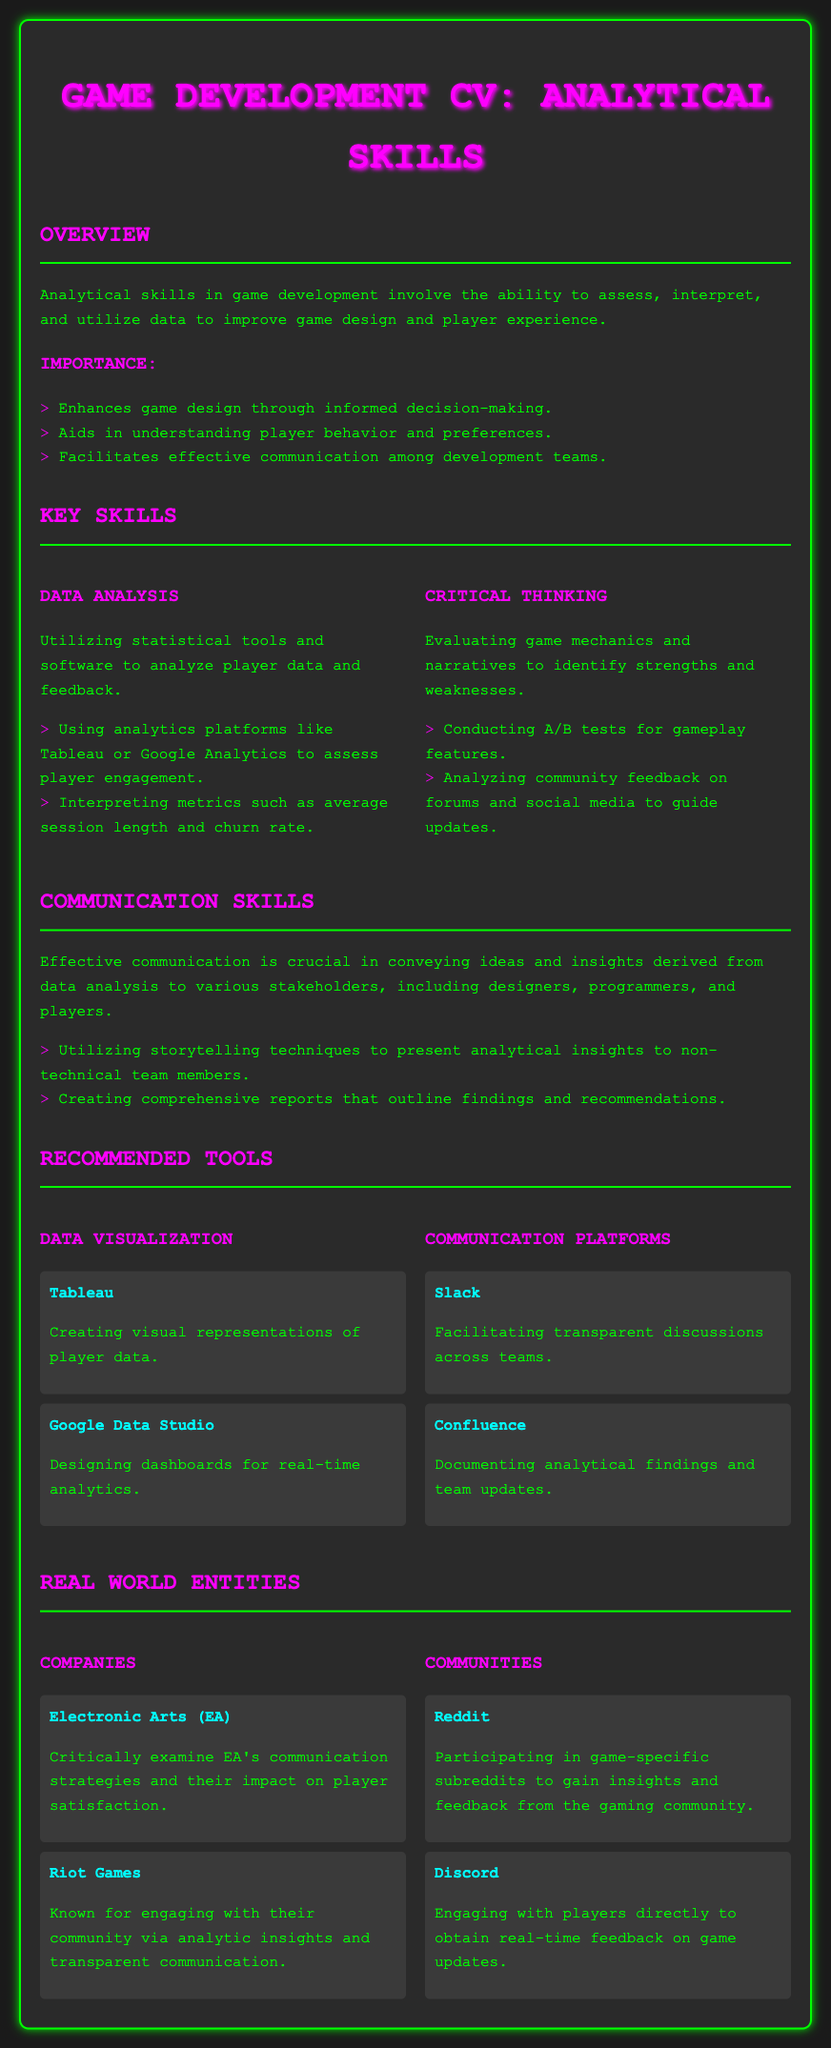what is the title of the document? The title of the document is mentioned in the <title> tag of the HTML, which is "Game Development CV - Analytical Skills."
Answer: Game Development CV - Analytical Skills how many key skills are listed? The document mentions two key skills under the "Key Skills" section: Data Analysis and Critical Thinking.
Answer: 2 which platform is used for data visualization? Tableau is mentioned as one of the tools for creating visual representations of player data.
Answer: Tableau what communication platform is mentioned for team discussions? Slack is noted as a platform that facilitates transparent discussions across teams.
Answer: Slack which company is critically examined for its communication strategies? The document states that Electronic Arts (EA) is examined for its communication strategies and their impact on player satisfaction.
Answer: Electronic Arts (EA) what community platform is used for real-time player feedback? Discord is referenced as a platform for engaging with players directly to obtain real-time feedback on game updates.
Answer: Discord what is the purpose of data analysis in game development? The overview section explains that analytical skills involve assessing, interpreting, and utilizing data to improve game design and player experience.
Answer: Improve game design and player experience how many communities are listed in the document? There are two communities mentioned: Reddit and Discord.
Answer: 2 what is a crucial skill for presenting analytical insights to non-technical team members? The document states that utilizing storytelling techniques is crucial for presenting analytical insights to non-technical team members.
Answer: Storytelling techniques 